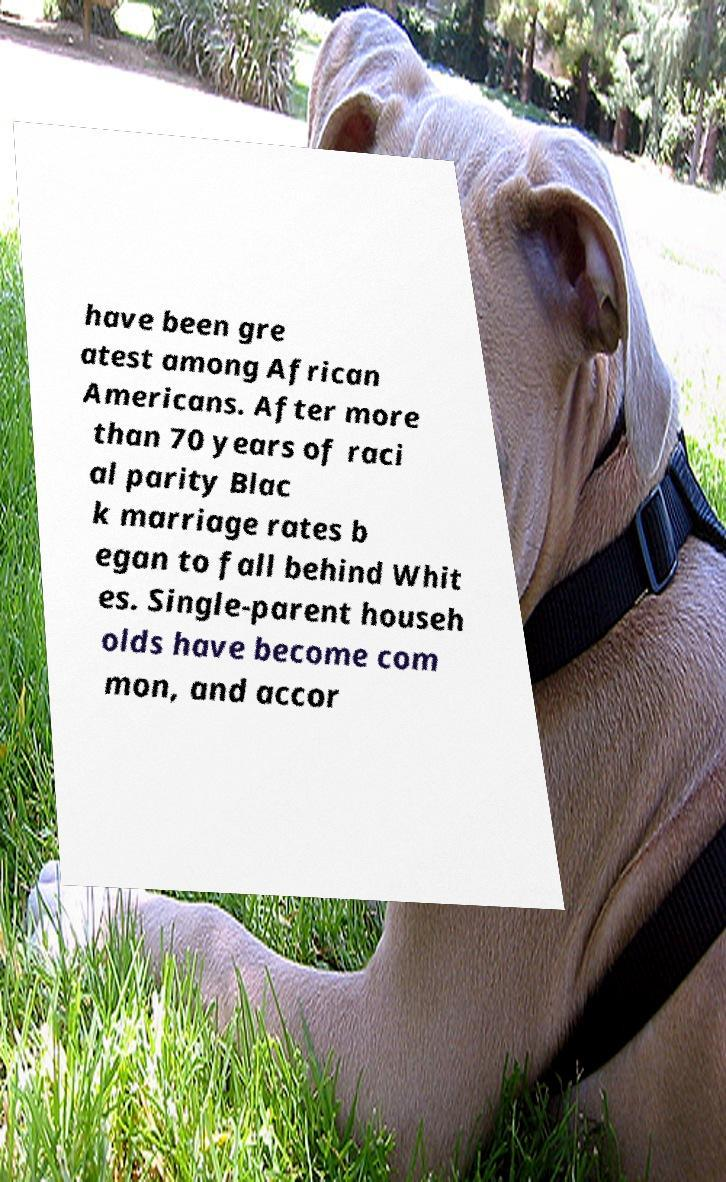There's text embedded in this image that I need extracted. Can you transcribe it verbatim? have been gre atest among African Americans. After more than 70 years of raci al parity Blac k marriage rates b egan to fall behind Whit es. Single-parent househ olds have become com mon, and accor 